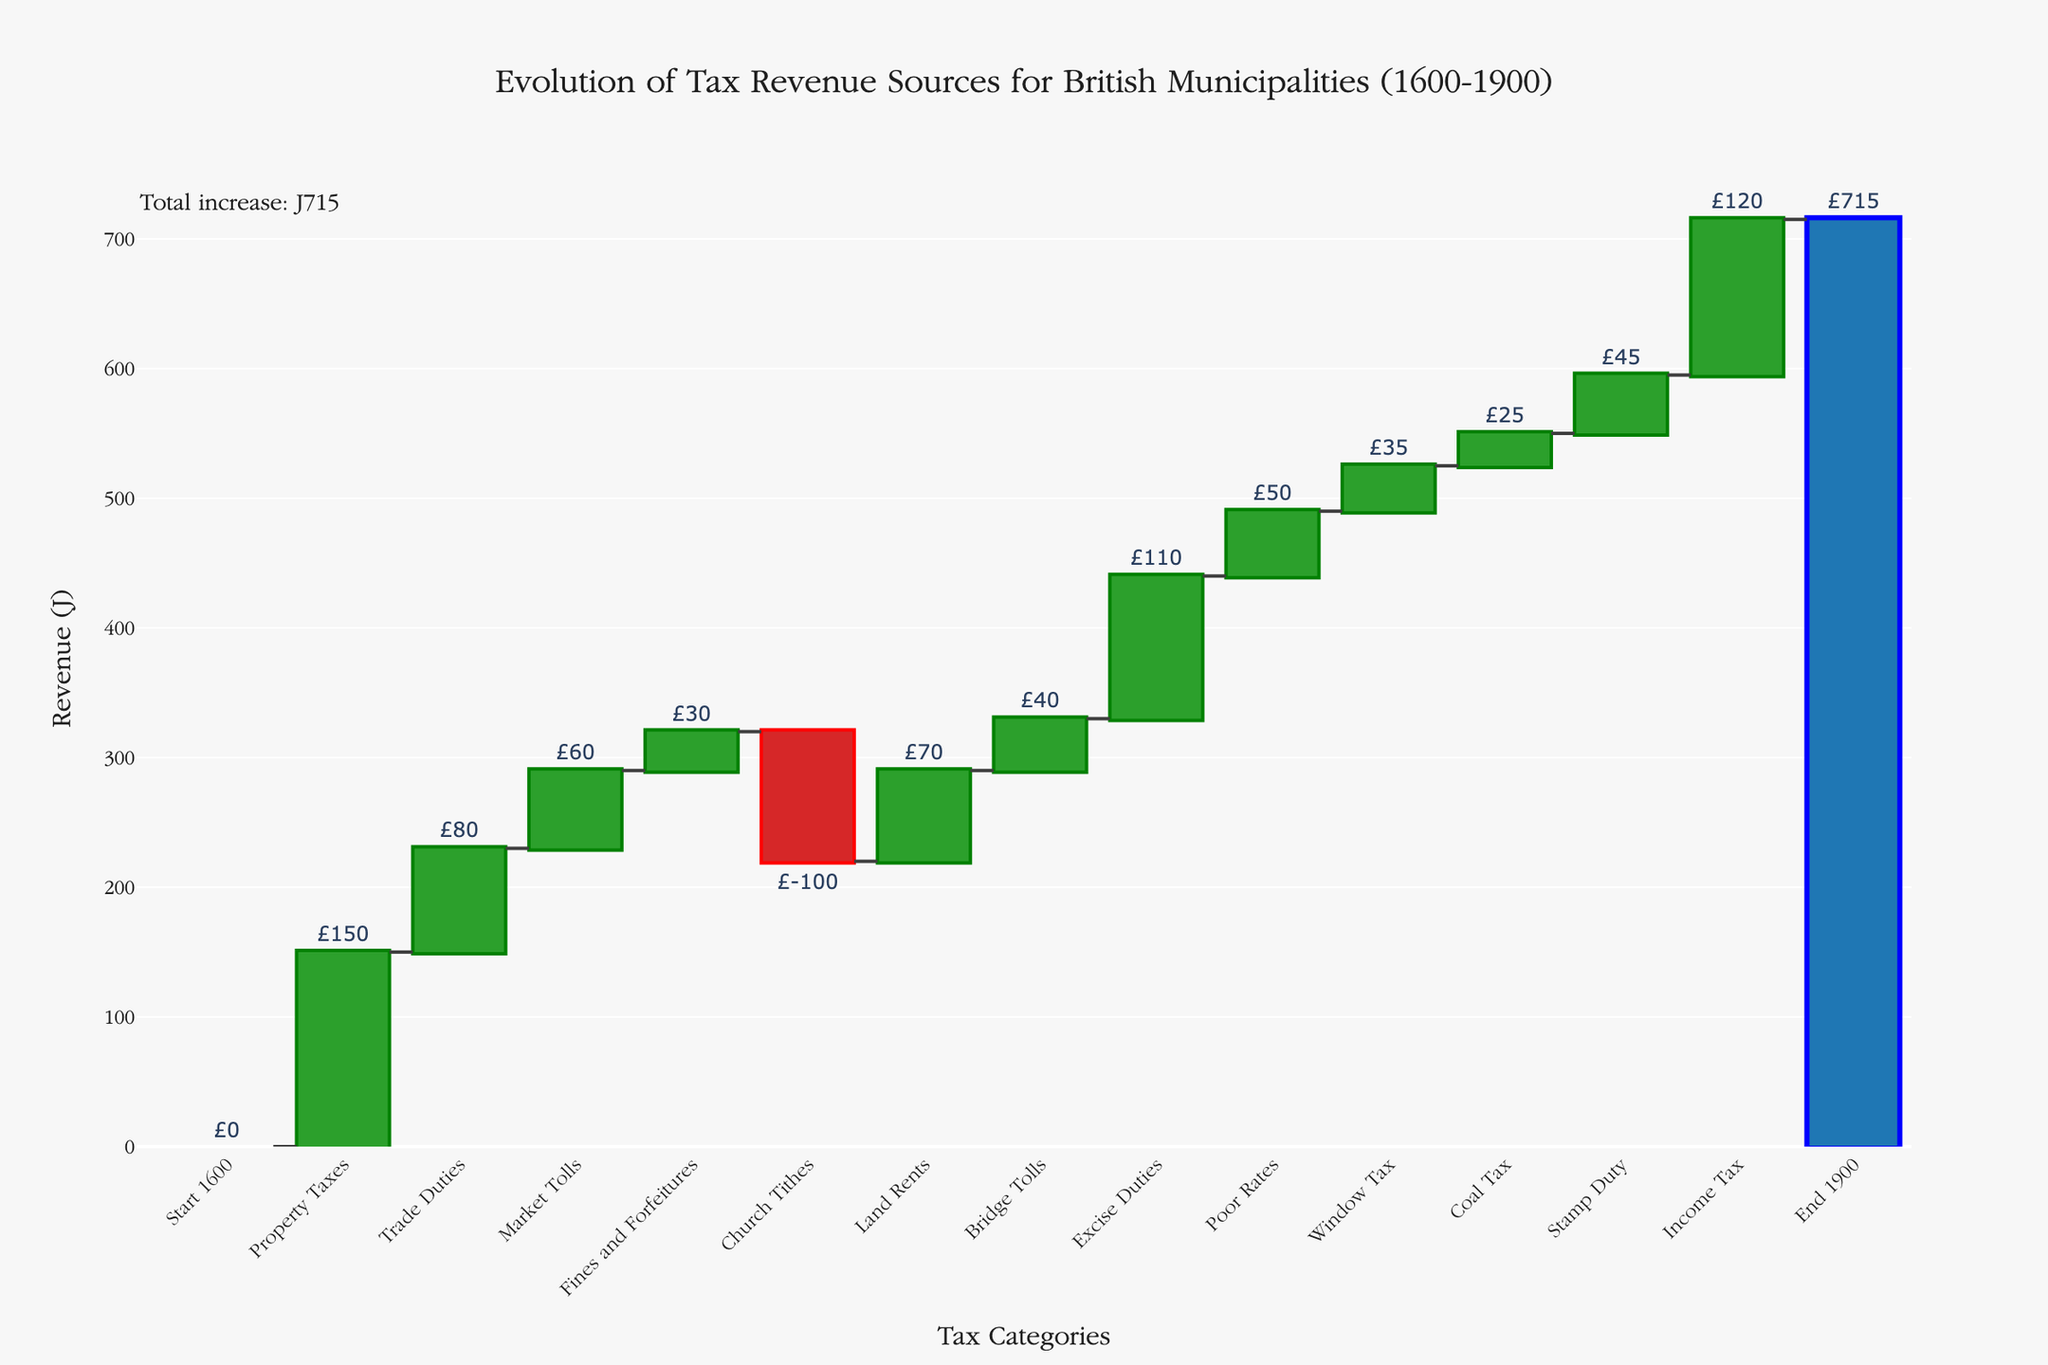What is the title of the chart? The title is usually found at the top of the chart. It provides a brief description of what the chart represents. In this case, it reads "Evolution of Tax Revenue Sources for British Municipalities (1600-1900)"
Answer: Evolution of Tax Revenue Sources for British Municipalities (1600-1900) How many categories of tax revenues are shown in the chart? To answer this, count the total number of categories listed on the x-axis, excluding 'Start 1600' and 'End 1900'. There are 13 categories of tax revenues shown.
Answer: 13 What was the total increase in tax revenues by 1900? The total increase is usually shown as the difference between the starting point and the ending point. Here, it is explicitly mentioned near the 'End 1900' bar. The annotation in the chart shows "Total increase: £715".
Answer: £715 Which tax category contributed the highest positive revenue change? Look for the tallest bar moving upwards (increasing) from the baseline. In this chart, the bar for 'Income Tax' appears to be the tallest contributing a positive revenue change of £120.
Answer: Income Tax Which category contributed the largest negative revenue change? Look for the bar that moves downwards (decreasing) the most from the baseline. 'Church Tithes' had a significant negative contribution of £-100.
Answer: Church Tithes What is the sum of the contributions from 'Trade Duties' and 'Market Tolls'? Identify the values for 'Trade Duties' (£80) and 'Market Tolls' (£60), and then add them together. \( 80 + 60 = 140 \).
Answer: £140 Compare the revenue contributions from 'Excise Duties' and 'Poor Rates'. Which one contributed more? 'Excise Duties' has a bar of £110, while 'Poor Rates' has a bar of £50. Clearly, 'Excise Duties' contributed more than 'Poor Rates'.
Answer: Excise Duties What is the difference in contributions between 'Property Taxes' and 'Land Rents'? Find the values for 'Property Taxes' (£150) and 'Land Rents' (£70) and calculate the difference. \( 150 - 70 = 80 \).
Answer: £80 What are the categories that have a revenue contribution of more than £50 but less than £100? Scan through the bars and identify the categories within this range. 'Trade Duties' (£80), 'Market Tolls' (£60), 'Land Rents' (£70), and 'Bridge Tolls' (£40) satisfy this condition.
Answer: Trade Duties, Market Tolls, and Land Rents What is the average revenue from all the tax categories, excluding 'Start 1600' and 'End 1900'? Sum the values of all tax categories, then divide by the number of categories. Categories: £150 + £80 + £60 + £30 - £100 + £70 + £40 + £110 + £50 + £35 + £25 + £45 + £120 = £715. Thus, the average is \( 715 / 13 = 55 \).
Answer: £55 